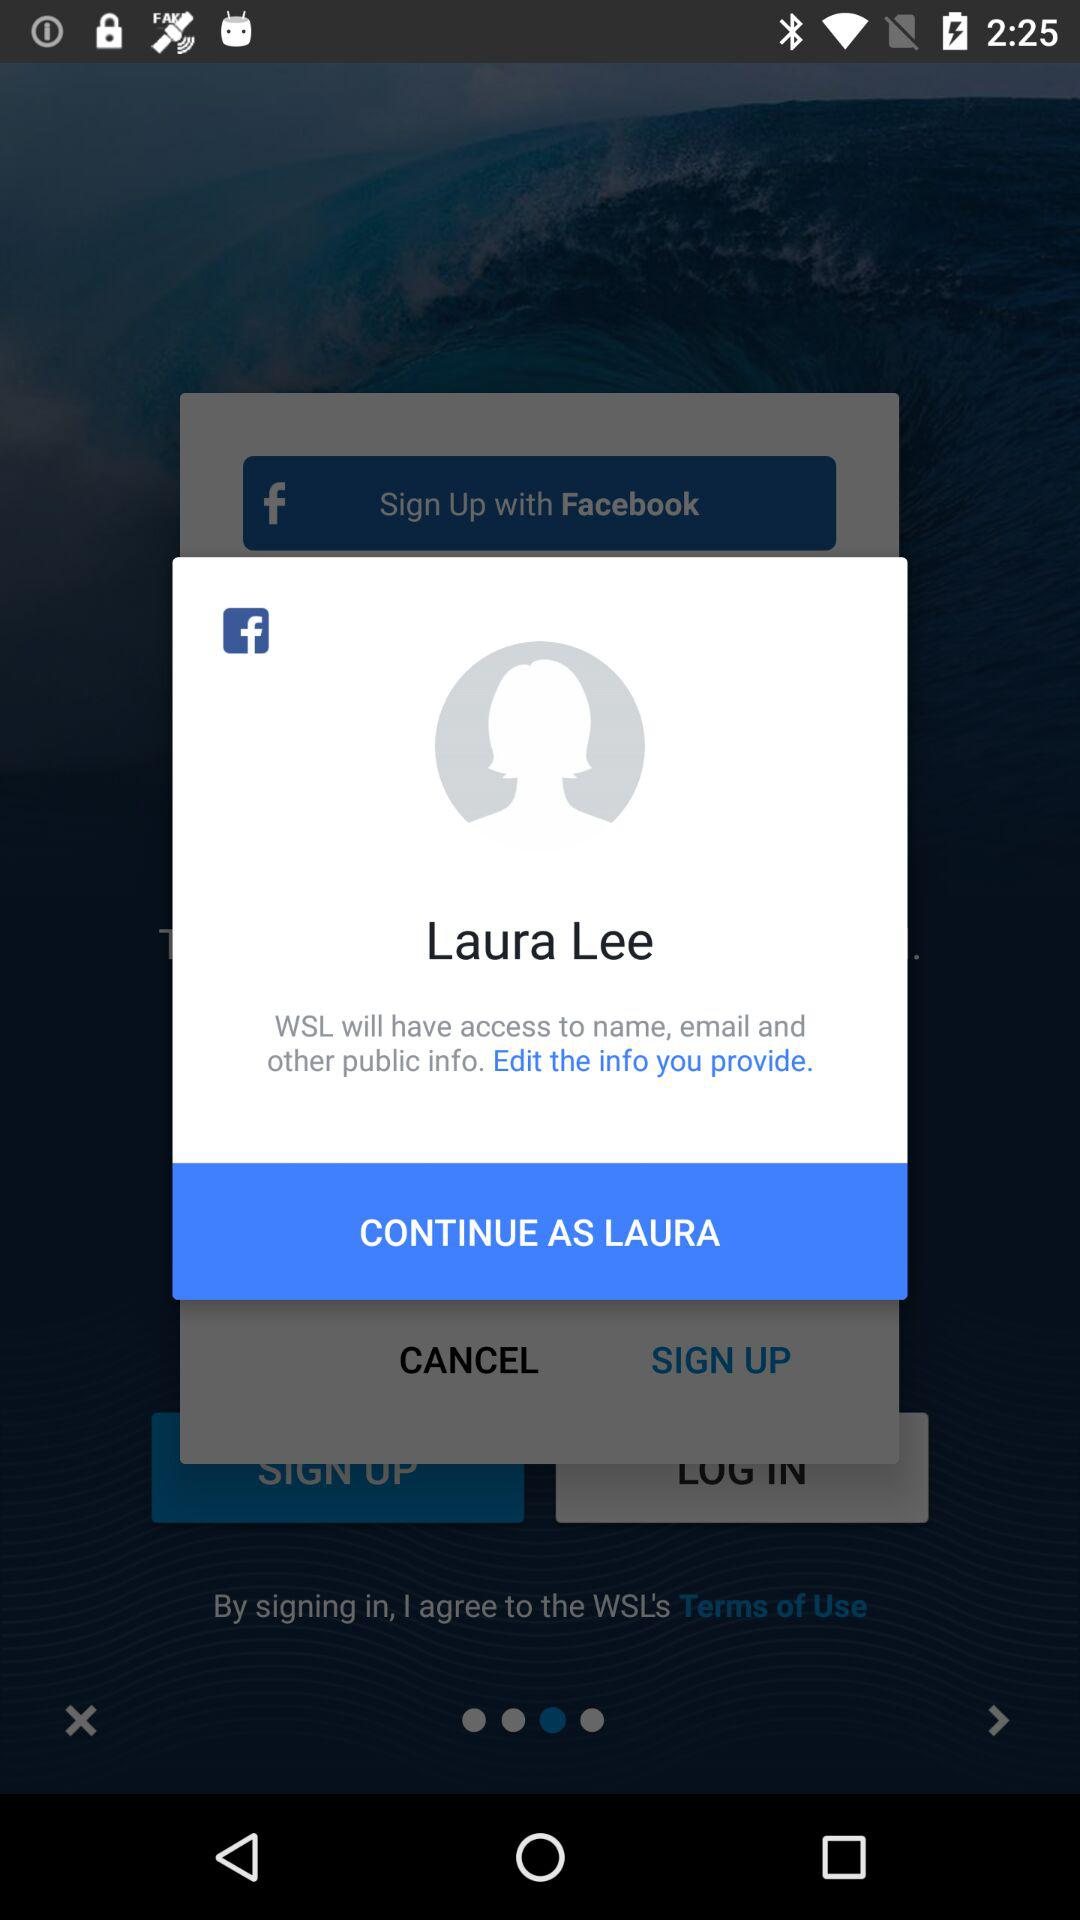What is the name of the user? The name of the user is Laura Lee. 